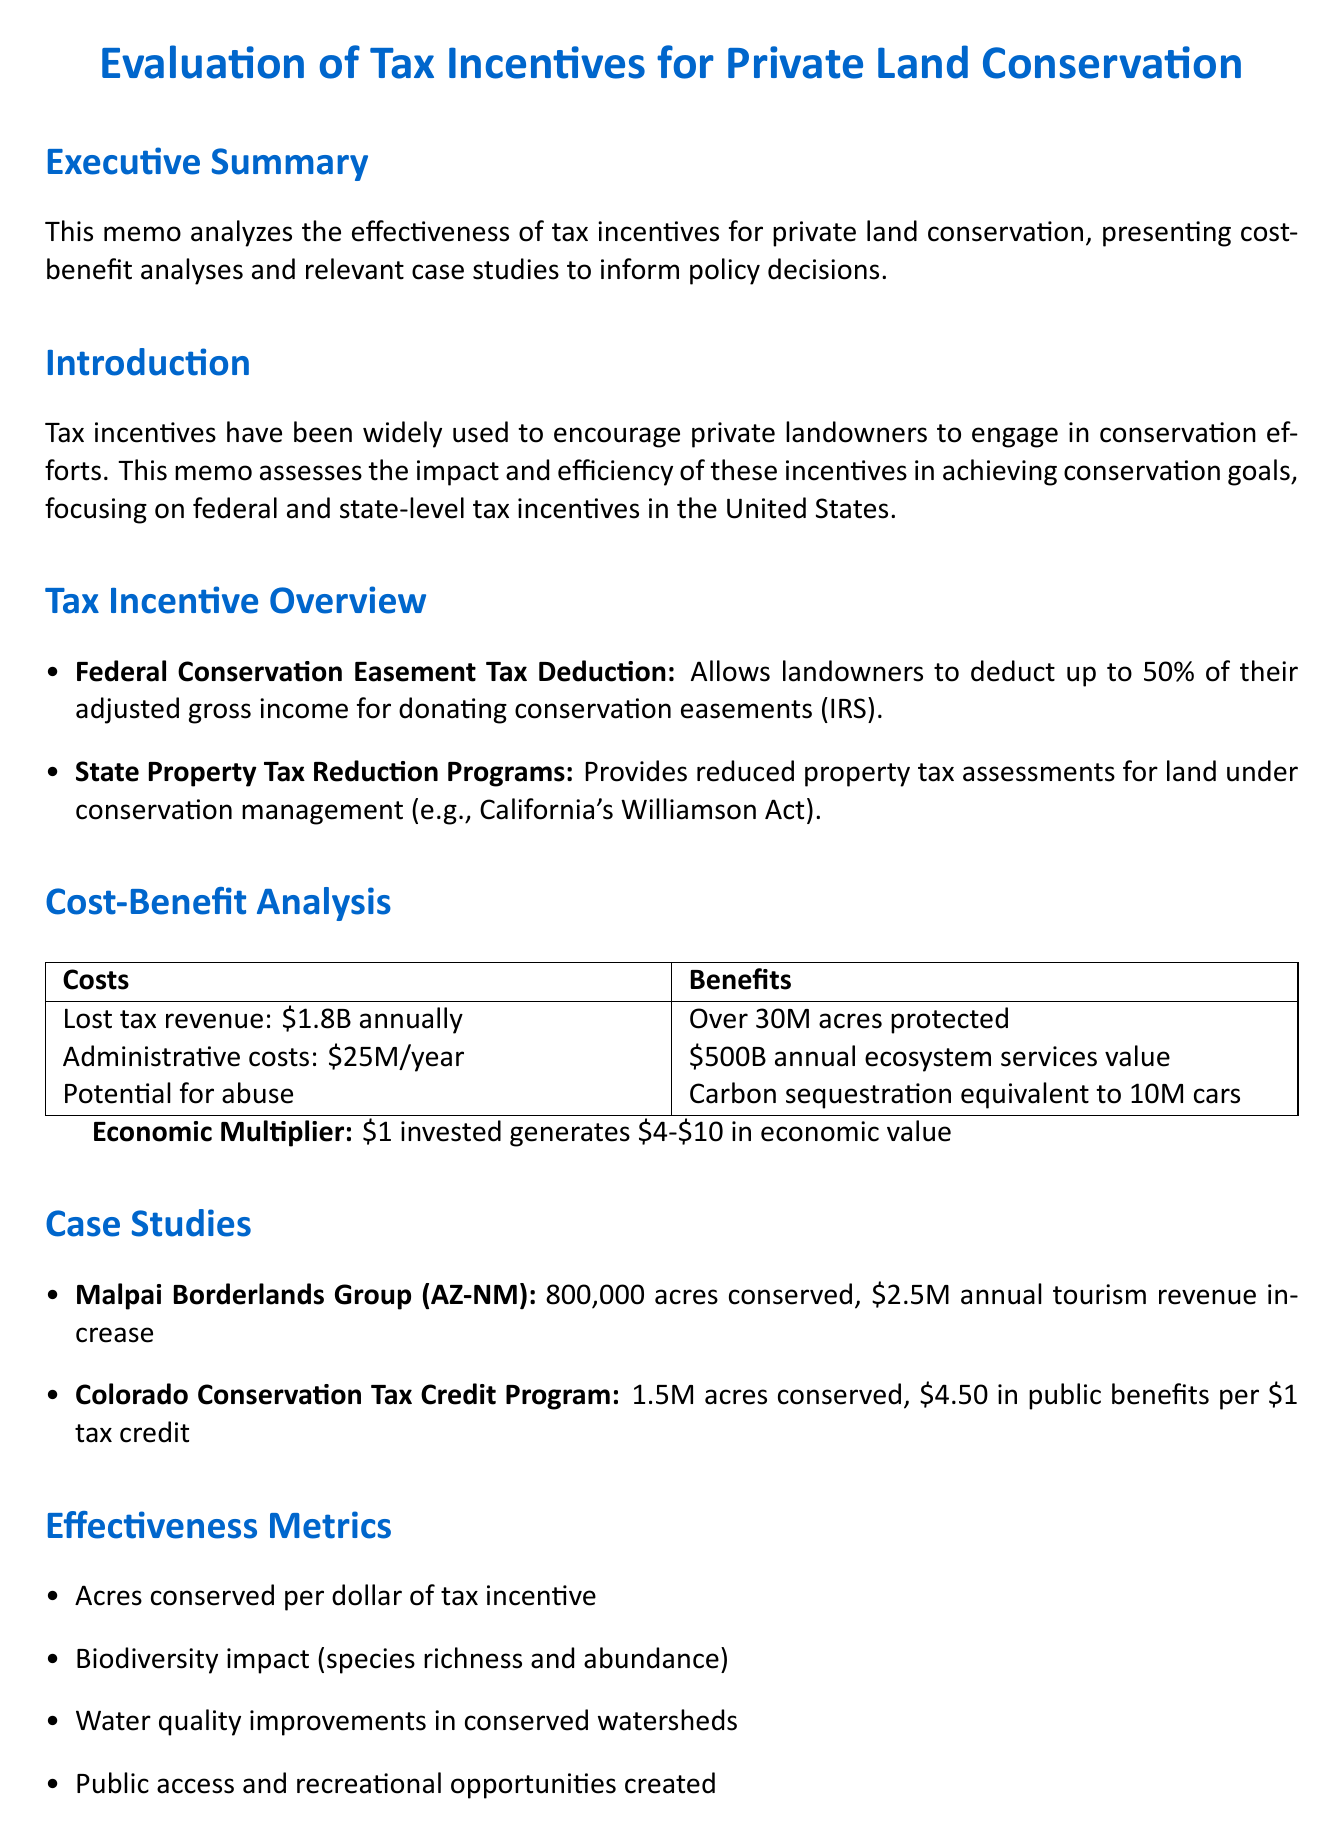What is the title of the memo? The title provides the main subject of the memo, which is an evaluation of tax incentives for conservation.
Answer: Evaluation of Tax Incentives for Private Land Conservation What is the implementing agency for the Federal Conservation Easement Tax Deduction? This agency is responsible for administering the tax deduction program outlined in the document.
Answer: Internal Revenue Service (IRS) What is the estimated annual lost tax revenue from federal conservation easement deductions? This figure reveals the financial impact of the tax deduction on federal revenue.
Answer: $1.8 billion How many acres have been conserved through the Colorado Conservation Tax Credit Program since 2000? This information sheds light on the effectiveness of the program in land conservation.
Answer: 1.5 million acres What is the estimated annual value of ecosystem services from protected lands? This value indicates the economic benefits generated by conserved areas, showcasing their importance.
Answer: $500 billion What challenge is associated with long-term monitoring and enforcement? This challenge identifies a major issue in ensuring the effectiveness of conservation efforts over time.
Answer: Long-term monitoring and enforcement What is a recommendation for ensuring additionality of conservation efforts? This recommendation suggests a method to improve the effectiveness of conservation activities.
Answer: Implement stricter criteria for qualifying conservation activities What does every $1 invested in conservation generate in economic value? This multiplier illustrates the economic benefits resulting from investments in conservation efforts.
Answer: $4-$10 What is the impact of the Malpai Borderlands Group's conservation efforts? This information highlights the success of the group in conserving land and promoting local economic benefits.
Answer: 800,000 acres conserved through ranch conservation easements 